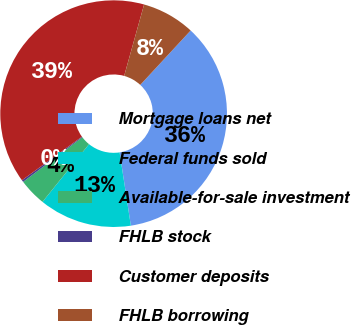<chart> <loc_0><loc_0><loc_500><loc_500><pie_chart><fcel>Mortgage loans net<fcel>Federal funds sold<fcel>Available-for-sale investment<fcel>FHLB stock<fcel>Customer deposits<fcel>FHLB borrowing<nl><fcel>35.68%<fcel>13.23%<fcel>3.92%<fcel>0.28%<fcel>39.33%<fcel>7.56%<nl></chart> 